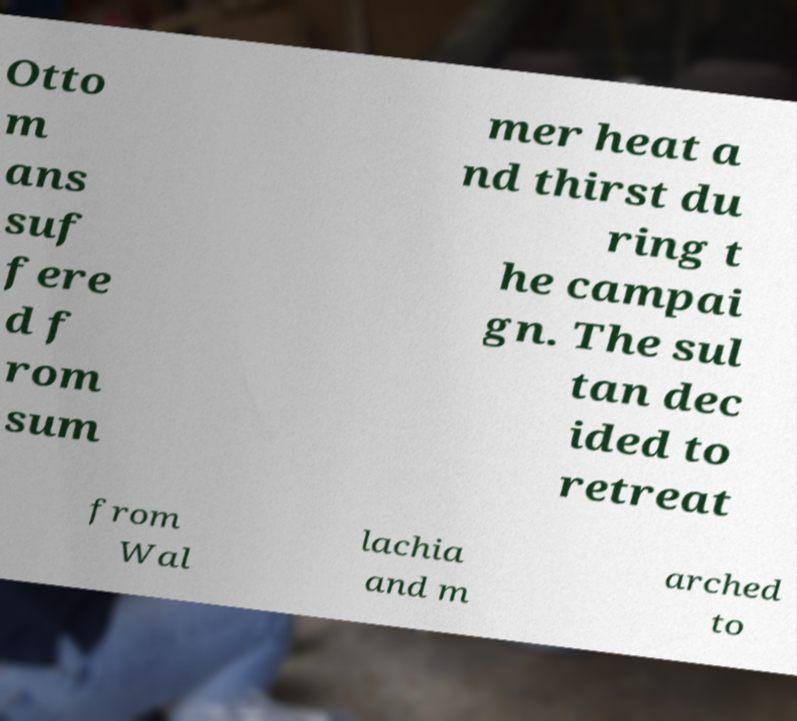For documentation purposes, I need the text within this image transcribed. Could you provide that? Otto m ans suf fere d f rom sum mer heat a nd thirst du ring t he campai gn. The sul tan dec ided to retreat from Wal lachia and m arched to 